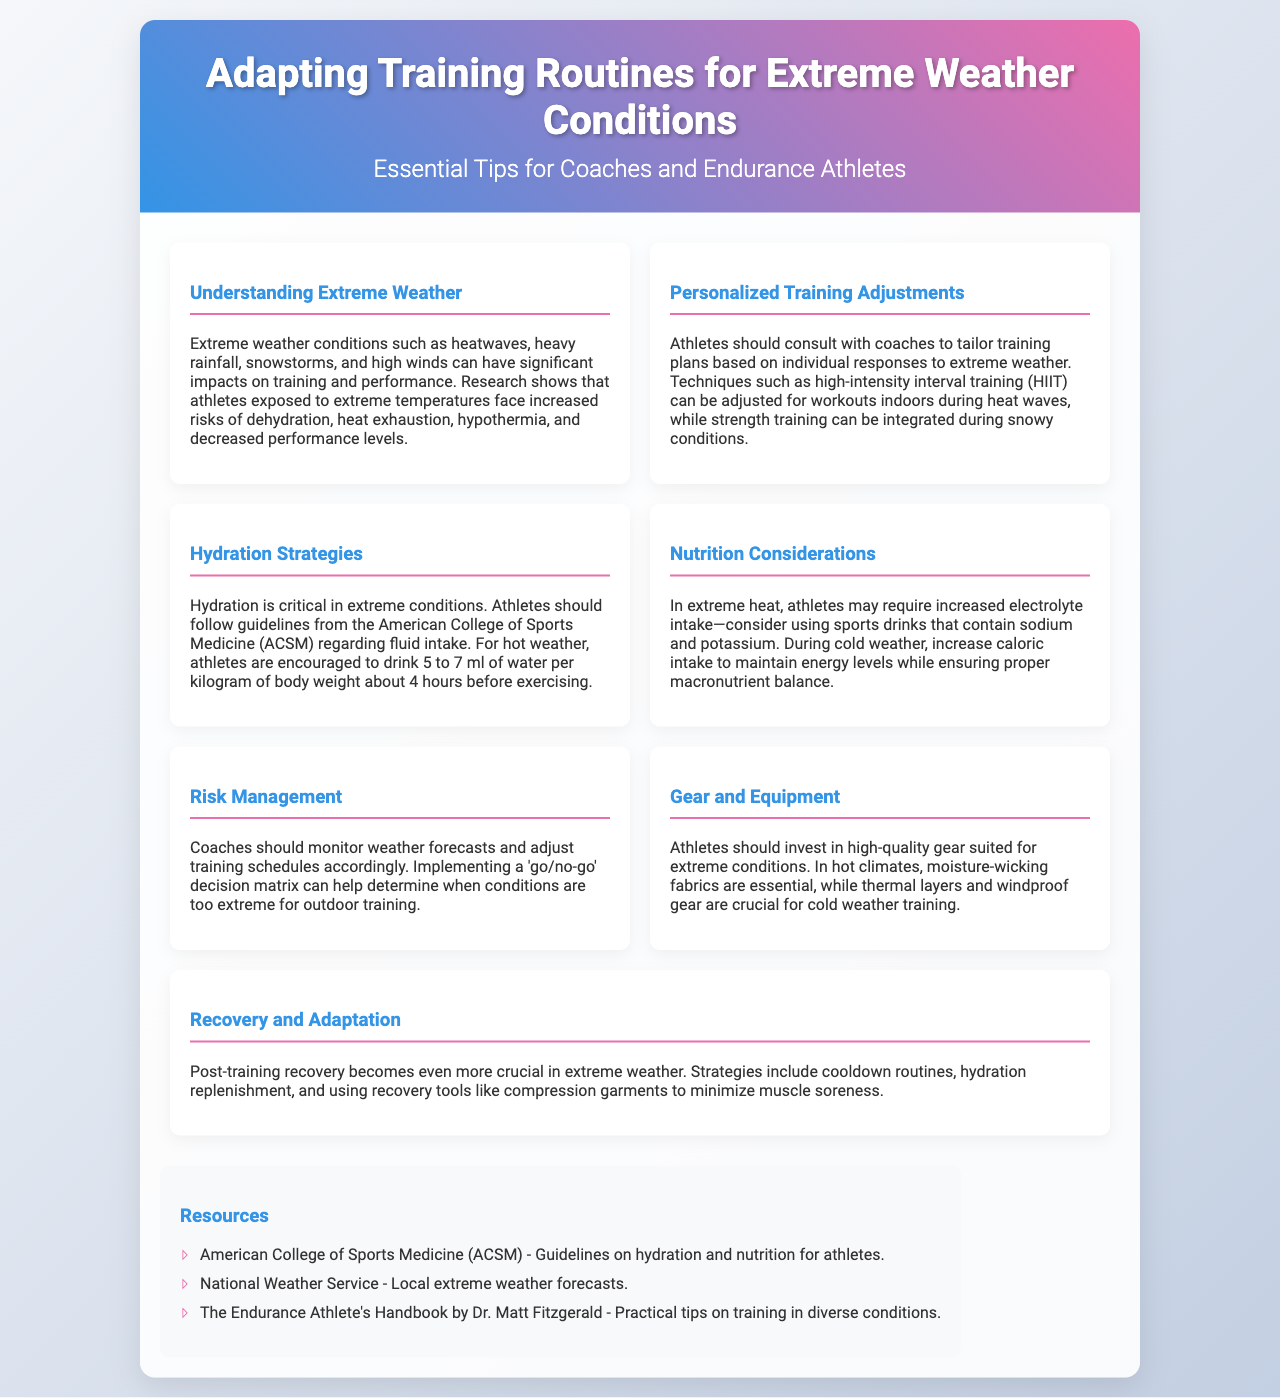What are extreme weather conditions that affect athletes? The document lists heatwaves, heavy rainfall, snowstorms, and high winds as extreme weather conditions that can impact training and performance.
Answer: Heatwaves, heavy rainfall, snowstorms, high winds What should athletes consult with coaches about? Athletes should consult with coaches to tailor training plans based on individual responses to extreme weather conditions.
Answer: Tailor training plans What hydrating amount is recommended before exercising? The document specifies that athletes are encouraged to drink 5 to 7 ml of water per kilogram of body weight about 4 hours before exercising in hot weather.
Answer: 5 to 7 ml What dietary adjustment is suggested for extreme heat? In extreme heat, athletes may require increased electrolyte intake, particularly through sports drinks that contain sodium and potassium.
Answer: Increased electrolyte intake What decision-making tool can coaches implement? Coaches can implement a 'go/no-go' decision matrix to determine when conditions are too extreme for outdoor training.
Answer: 'Go/no-go' decision matrix Which materials are important for hot climate gear? The document mentions that moisture-wicking fabrics are essential for athletes training in hot climates.
Answer: Moisture-wicking fabrics What recovery strategies are highlighted for extreme weather? Strategies highlighted for post-training recovery include cooldown routines, hydration replenishment, and using recovery tools like compression garments to minimize muscle soreness.
Answer: Cooldown routines, hydration replenishment, compression garments How many resources are listed in the document? The document lists a total of three resources for further information and guidance on extreme weather training adaptations.
Answer: Three resources 